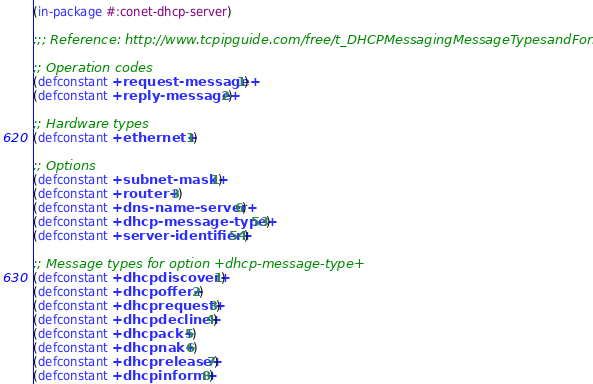Convert code to text. <code><loc_0><loc_0><loc_500><loc_500><_Lisp_>(in-package #:conet-dhcp-server)

;;; Reference: http://www.tcpipguide.com/free/t_DHCPMessagingMessageTypesandFormats.htm

;; Operation codes
(defconstant +request-message+ 1)
(defconstant +reply-message+ 2)

;; Hardware types
(defconstant +ethernet+ 1)

;; Options
(defconstant +subnet-mask+ 1)
(defconstant +router+ 3)
(defconstant +dns-name-server+ 6)
(defconstant +dhcp-message-type+ 53)
(defconstant +server-identifier+ 54)

;; Message types for option +dhcp-message-type+
(defconstant +dhcpdiscover+ 1)
(defconstant +dhcpoffer+ 2)
(defconstant +dhcprequest+ 3)
(defconstant +dhcpdecline+ 4)
(defconstant +dhcpack+ 5)
(defconstant +dhcpnak+ 6)
(defconstant +dhcprelease+ 7)
(defconstant +dhcpinform+ 8)
</code> 